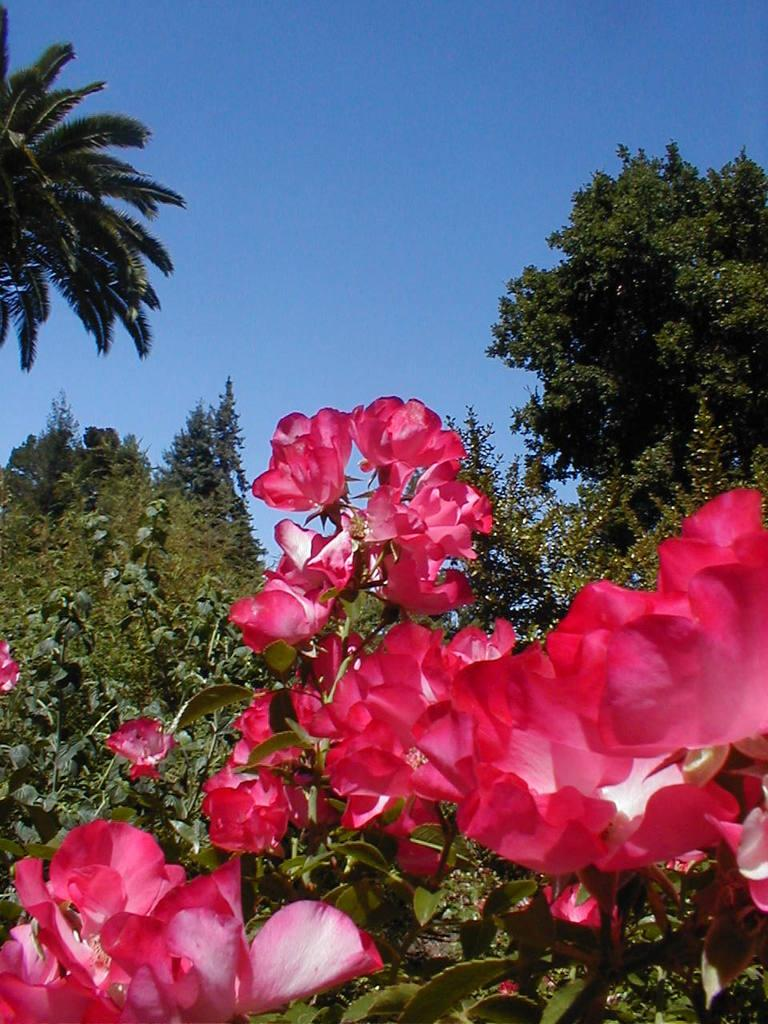What is located in the center of the image? There are trees, plants, and flowers in the center of the image. What color are the flowers in the image? The flowers in the image are red in color. What can be seen in the background of the image? There is a sky visible in the background of the image. What type of punishment is being given to the kitty in the image? There is no kitty present in the image, and therefore no punishment can be observed. What kind of toys are visible in the image? There are no toys visible in the image; it features trees, plants, and flowers. 